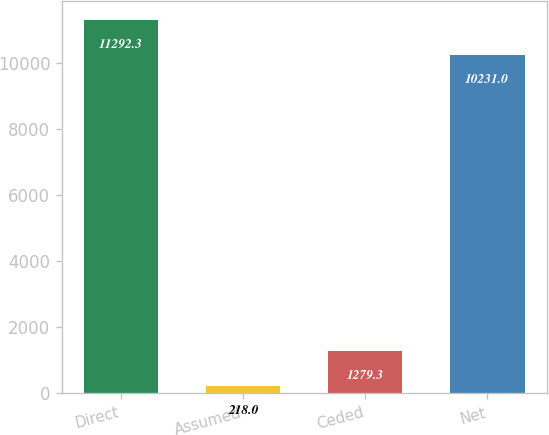Convert chart to OTSL. <chart><loc_0><loc_0><loc_500><loc_500><bar_chart><fcel>Direct<fcel>Assumed<fcel>Ceded<fcel>Net<nl><fcel>11292.3<fcel>218<fcel>1279.3<fcel>10231<nl></chart> 